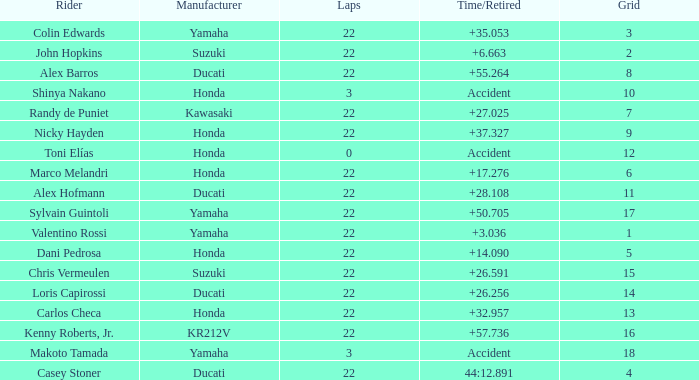What is the average grid for the competitiors who had laps smaller than 3? 12.0. 